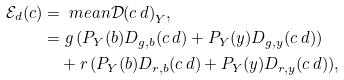<formula> <loc_0><loc_0><loc_500><loc_500>\mathcal { E } _ { d } ( c ) & = \ m e a n { \mathcal { D } ( c \, d ) } _ { Y } , \\ & = g \, ( P _ { Y } ( b ) D _ { g , b } ( c \, d ) + P _ { Y } ( y ) D _ { g , y } ( c \, d ) ) \\ & \quad + r \, ( P _ { Y } ( b ) D _ { r , b } ( c \, d ) + P _ { Y } ( y ) D _ { r , y } ( c \, d ) ) ,</formula> 